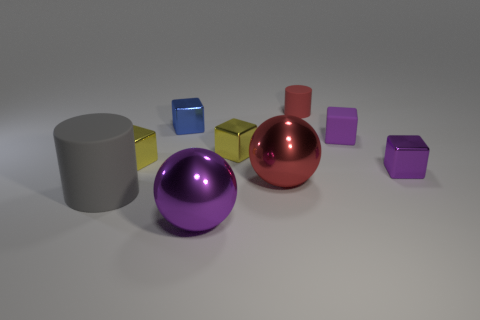Are there any large objects that are in front of the rubber object that is left of the blue shiny object?
Give a very brief answer. Yes. There is a rubber thing that is the same shape as the tiny purple metallic object; what is its color?
Provide a succinct answer. Purple. There is a big metal object that is right of the big purple sphere; is its color the same as the large cylinder?
Offer a very short reply. No. What number of things are either tiny purple blocks in front of the red matte thing or purple balls?
Your answer should be very brief. 3. What is the small yellow cube that is in front of the yellow metal cube that is right of the ball that is in front of the gray rubber cylinder made of?
Ensure brevity in your answer.  Metal. Are there more small purple shiny objects behind the rubber cube than red metallic objects that are behind the small red cylinder?
Keep it short and to the point. No. What number of cylinders are small yellow objects or red objects?
Make the answer very short. 1. How many yellow things are left of the yellow thing to the right of the purple object in front of the big gray cylinder?
Provide a succinct answer. 1. What material is the ball that is the same color as the tiny matte cylinder?
Provide a short and direct response. Metal. Is the number of gray rubber objects greater than the number of metallic cubes?
Provide a succinct answer. No. 